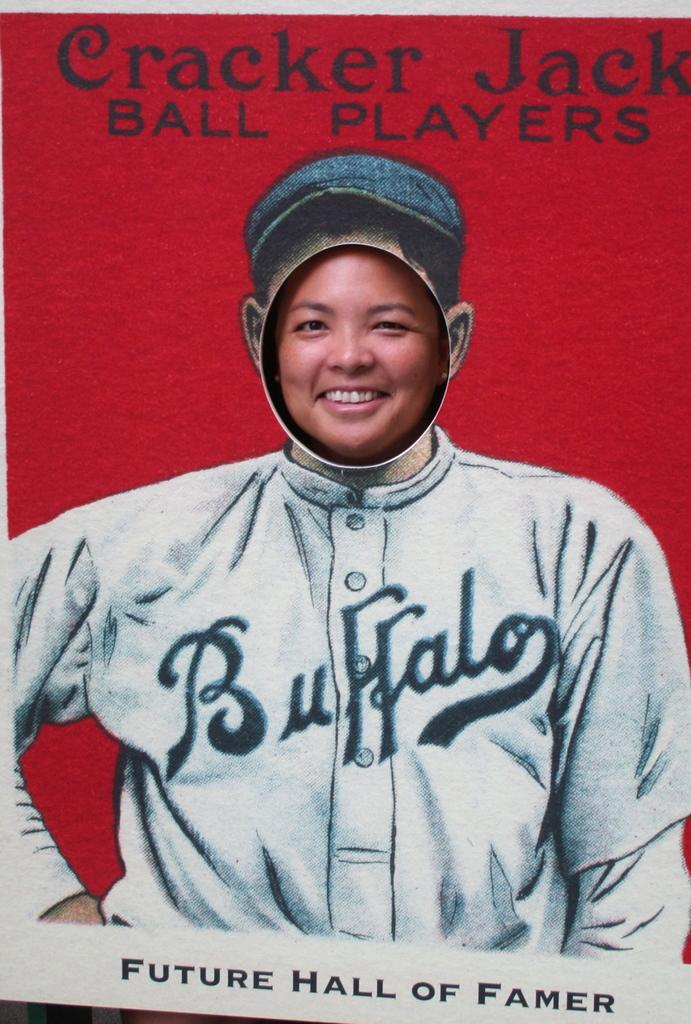<image>
Create a compact narrative representing the image presented. A poster that reads Cracker Jack Ball Players, shows a picture of a baseball player and the text Future Hall of Famer underneathe. 